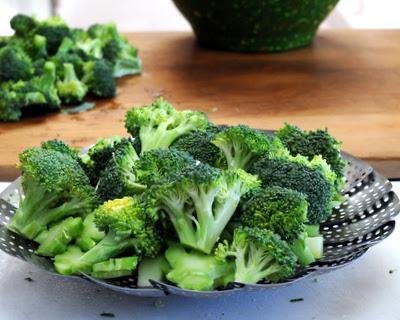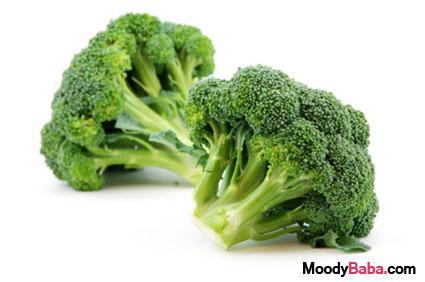The first image is the image on the left, the second image is the image on the right. Given the left and right images, does the statement "In 1 of the images, there is broccoli on a plate." hold true? Answer yes or no. Yes. The first image is the image on the left, the second image is the image on the right. For the images shown, is this caption "One image shows broccoli florets in a collander shaped like a dish." true? Answer yes or no. Yes. 